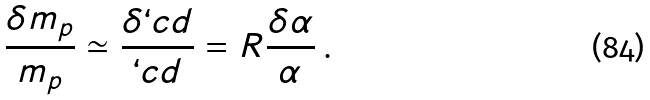Convert formula to latex. <formula><loc_0><loc_0><loc_500><loc_500>\frac { \delta m _ { p } } { m _ { p } } \simeq \frac { \delta \lq c d } { \lq c d } = R \frac { \delta \alpha } { \alpha } \, .</formula> 